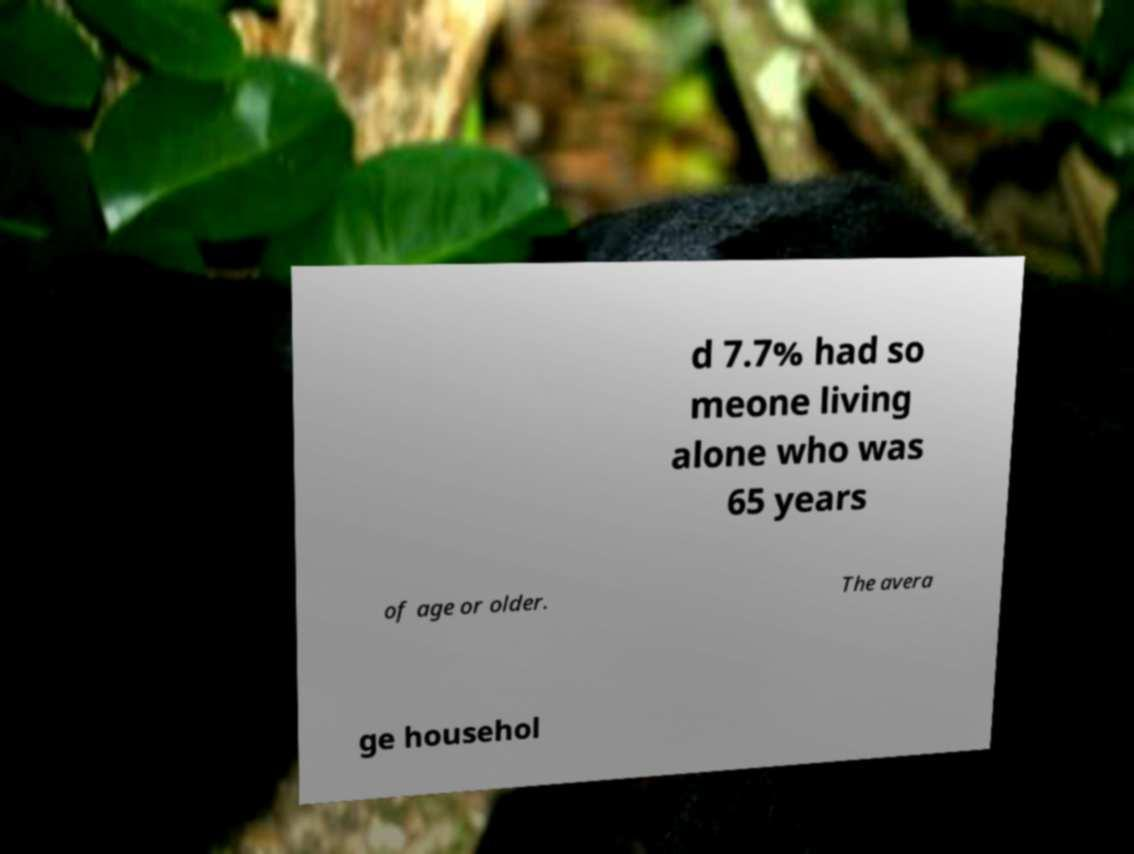Can you accurately transcribe the text from the provided image for me? d 7.7% had so meone living alone who was 65 years of age or older. The avera ge househol 